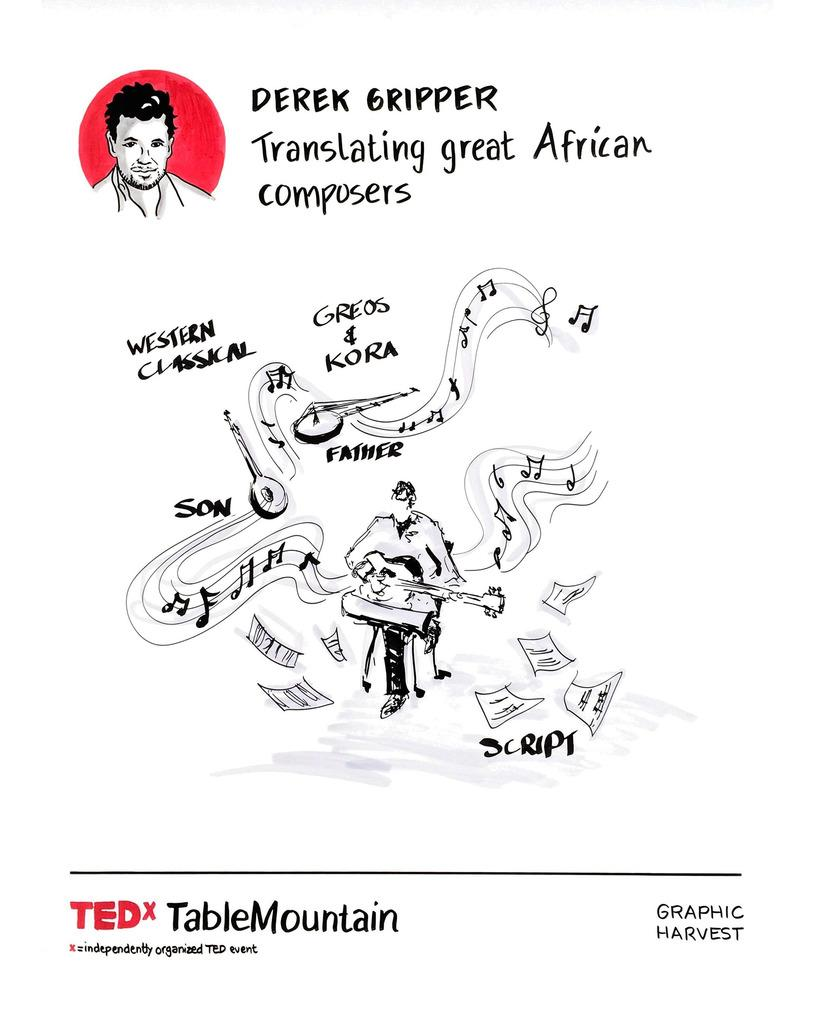What is featured in the image? There is a poster in the image. What is the person on the poster doing? The person on the poster is sitting and holding a musical instrument. What else can be seen on the poster besides the person? The poster has papers depicted and writing on it. Is there any image of a person on the poster? Yes, the poster includes a picture of a person. What type of curtain is hanging in front of the person on the poster? There is no curtain present in the image; it only features a poster with a person holding a musical instrument. 